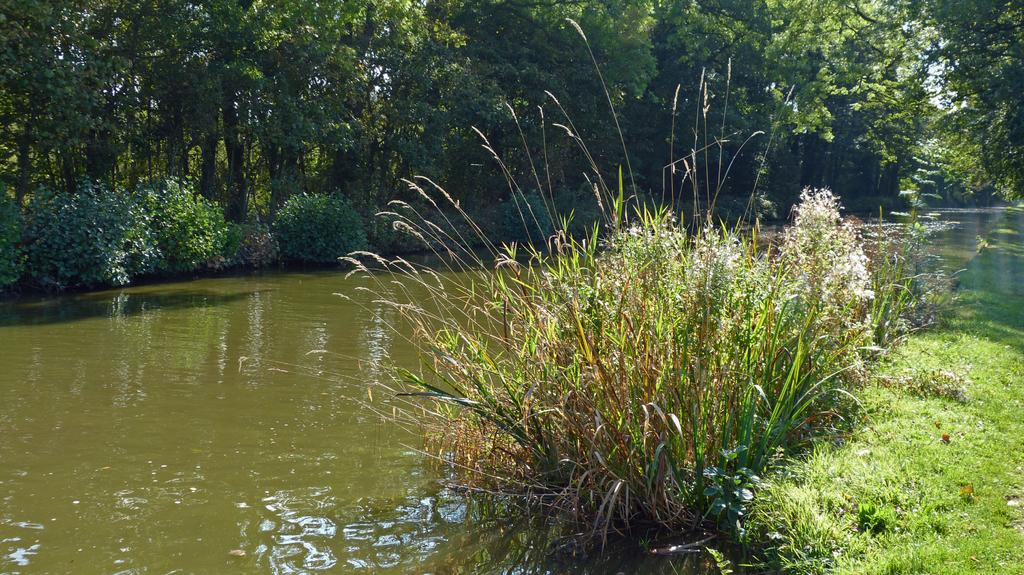What is one of the main elements visible in the image? Water is visible in the image. What type of vegetation can be seen in the image? There are plants and grass in the image. What can be seen in the background of the image? In the background, there are trees and additional plants. What type of flame can be seen in the image? There is no flame present in the image. Who is the partner of the person in the image? There is no person present in the image, so there is no partner to identify. 